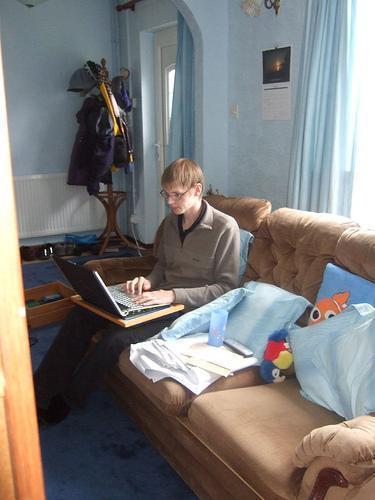The fish on the pillow goes by what name?
Choose the correct response, then elucidate: 'Answer: answer
Rationale: rationale.'
Options: Finbar, dory, nemo, flounder. Answer: nemo.
Rationale: An orange clown fish is on a pillow on a couch. 